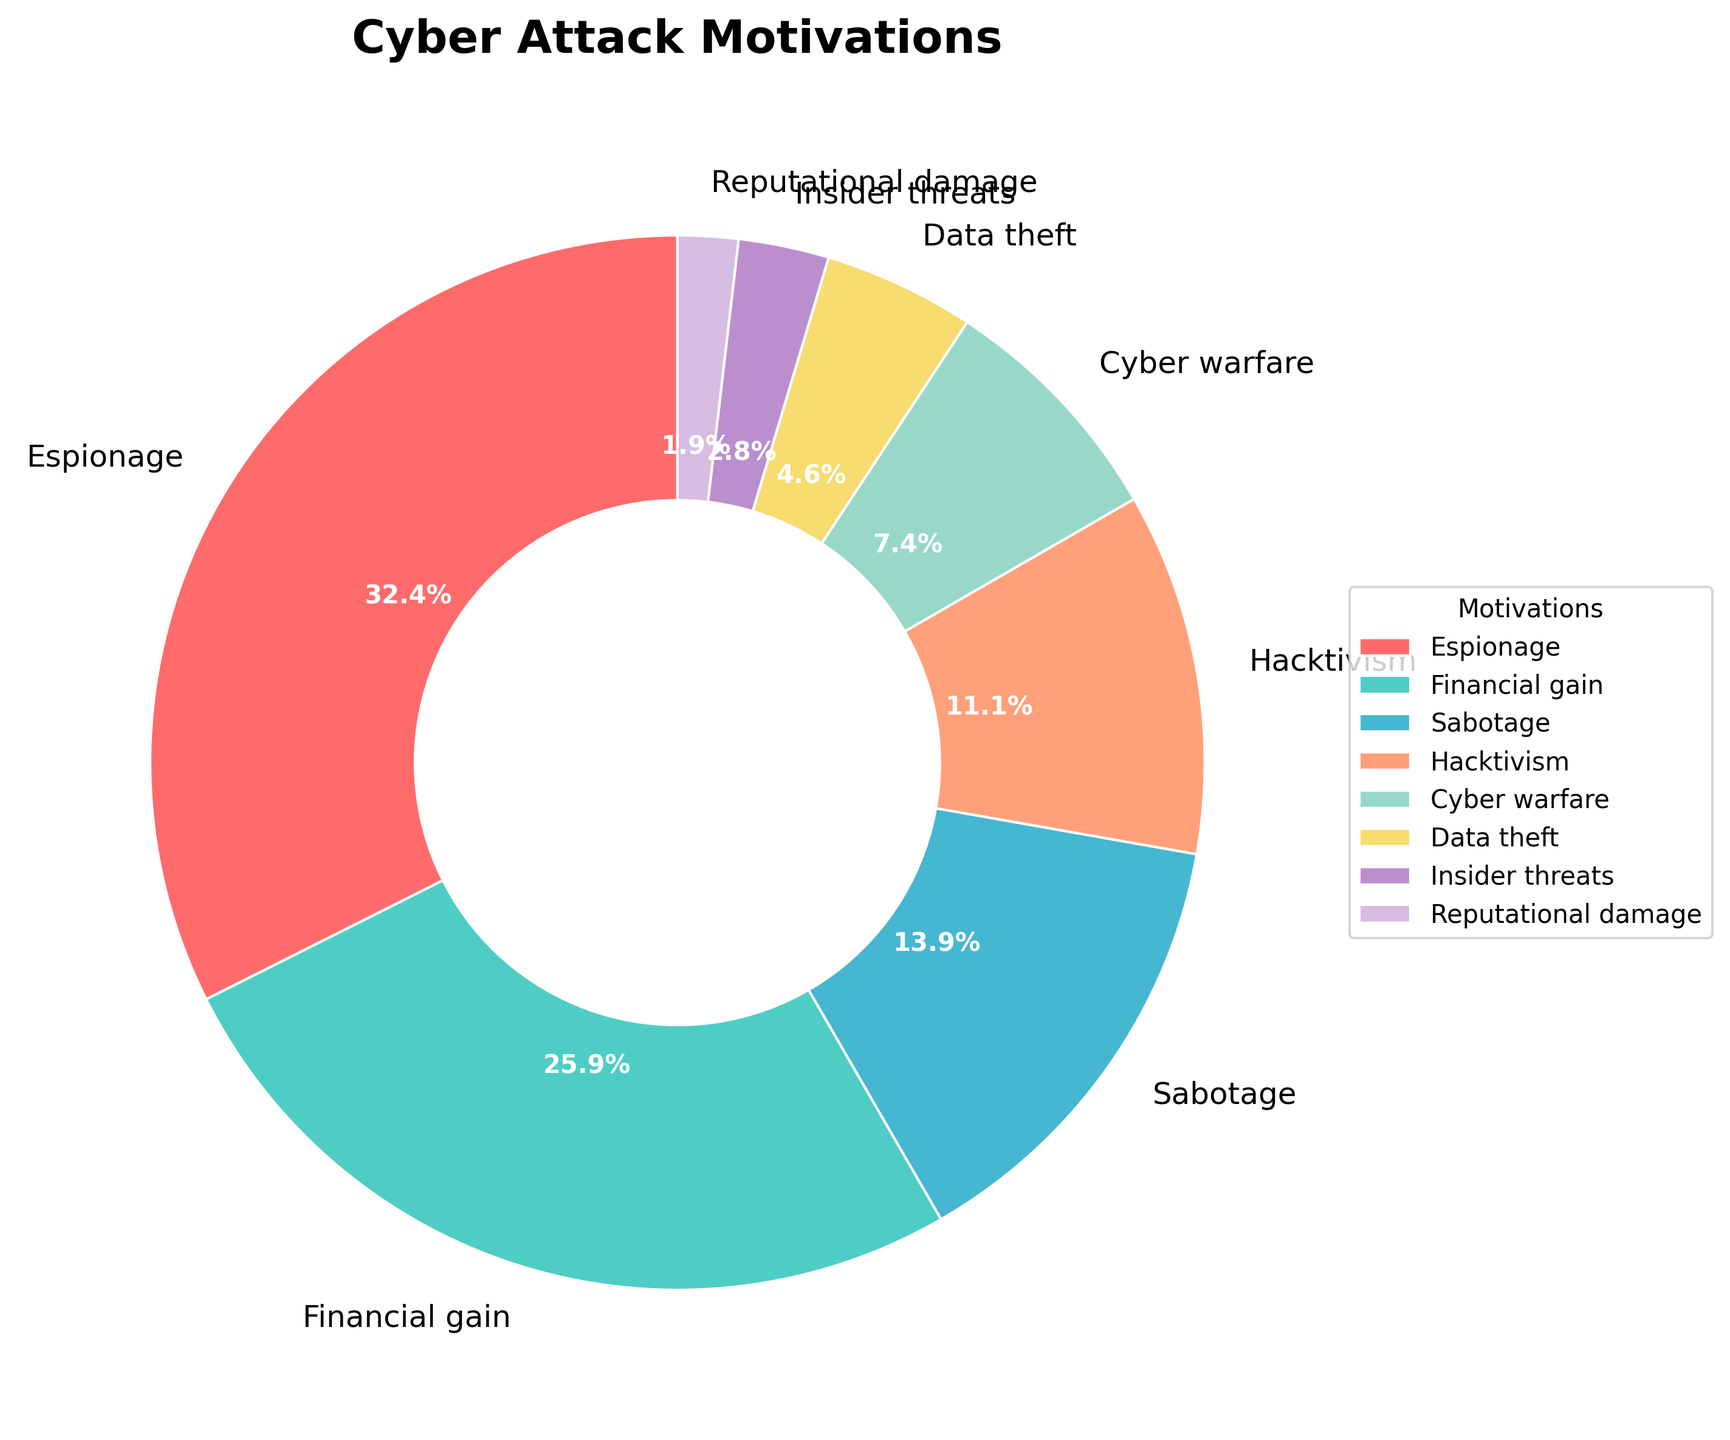What is the most common motivation for cyber attacks according to the chart? The wedge representing "Espionage" is the largest in the pie chart.
Answer: Espionage How do the percentages of financial gain and sabotage compare to each other? Financial gain is 28% while sabotage is 15%. Subtracting these percentages, we get 28% - 15% = 13%. Thus, financial gain is 13% higher than sabotage.
Answer: Financial gain is 13% higher Which motivation has the smallest percentage, and what is that percentage? The smallest wedge on the pie chart corresponds to "Reputational damage" which is 2%.
Answer: Reputational damage, 2% What fraction of cyber attacks are attributed to hacktivism and sabotage combined? Hacktivism is 12% and sabotage is 15%. Adding these two percentages, we get 12% + 15% = 27%.
Answer: 27% By how much does the percentage of espionage exceed that of cyber warfare? Espionage is 35%, and cyber warfare is 8%. Subtracting these percentages, we get 35% - 8% = 27%.
Answer: 27% Which motivations, if combined, equal the percentage of attacks attributed to financial gain? Combining sabotage (15%) and hacktivism (12%) equals 15% + 12% = 27%, which is close to financial gain's 28%. However, including insider threats (3%) gets us exactly 15% + 12% + 3% = 30%, slightly over 28%. Adjusting by combining slightly different motivations, data theft (5%) and sabotage (15%) exactly add up to 28%.
Answer: Data theft and sabotage How many motivations have a percentage higher than 10%? By examining the graph, there are four motivations with percentages higher than 10%: espionage (35%), financial gain (28%), sabotage (15%), and hacktivism (12%).
Answer: Four What is the combined percentage of all motivations except espionage? Summing the percentages of all other motivations: 28% (financial gain) + 15% (sabotage) + 12% (hacktivism) + 8% (cyber warfare) + 5% (data theft) + 3% (insider threats) + 2% (reputational damage) = 73%.
Answer: 73% Which color represents cyber warfare in the pie chart? The pie chart's fifth segment, starting from the first one positioned at the top-right in a clockwise direction, represents cyber warfare with a distinct color different from its neighbors.
Answer: [Based on the provided color description, which might differ per user visualization. Example: Yellow] Is the average percentage of espionage, financial gain, and sabotage greater than 25%? The average percentage is calculated as (35% + 28% + 15%) / 3 = 78% / 3 = 26%. Since 26% is greater than 25%, this condition is met.
Answer: Yes 